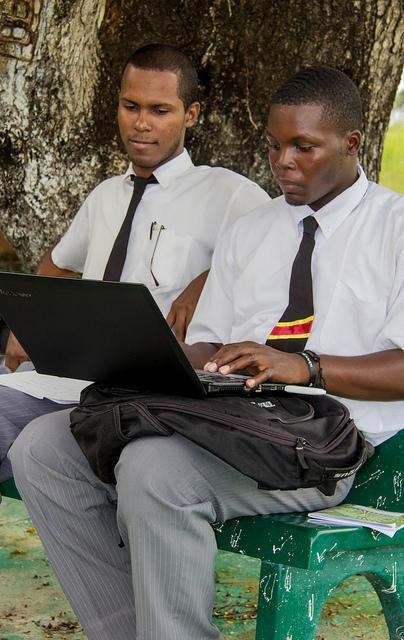How many people are there?
Give a very brief answer. 2. How many white cars do you see?
Give a very brief answer. 0. 